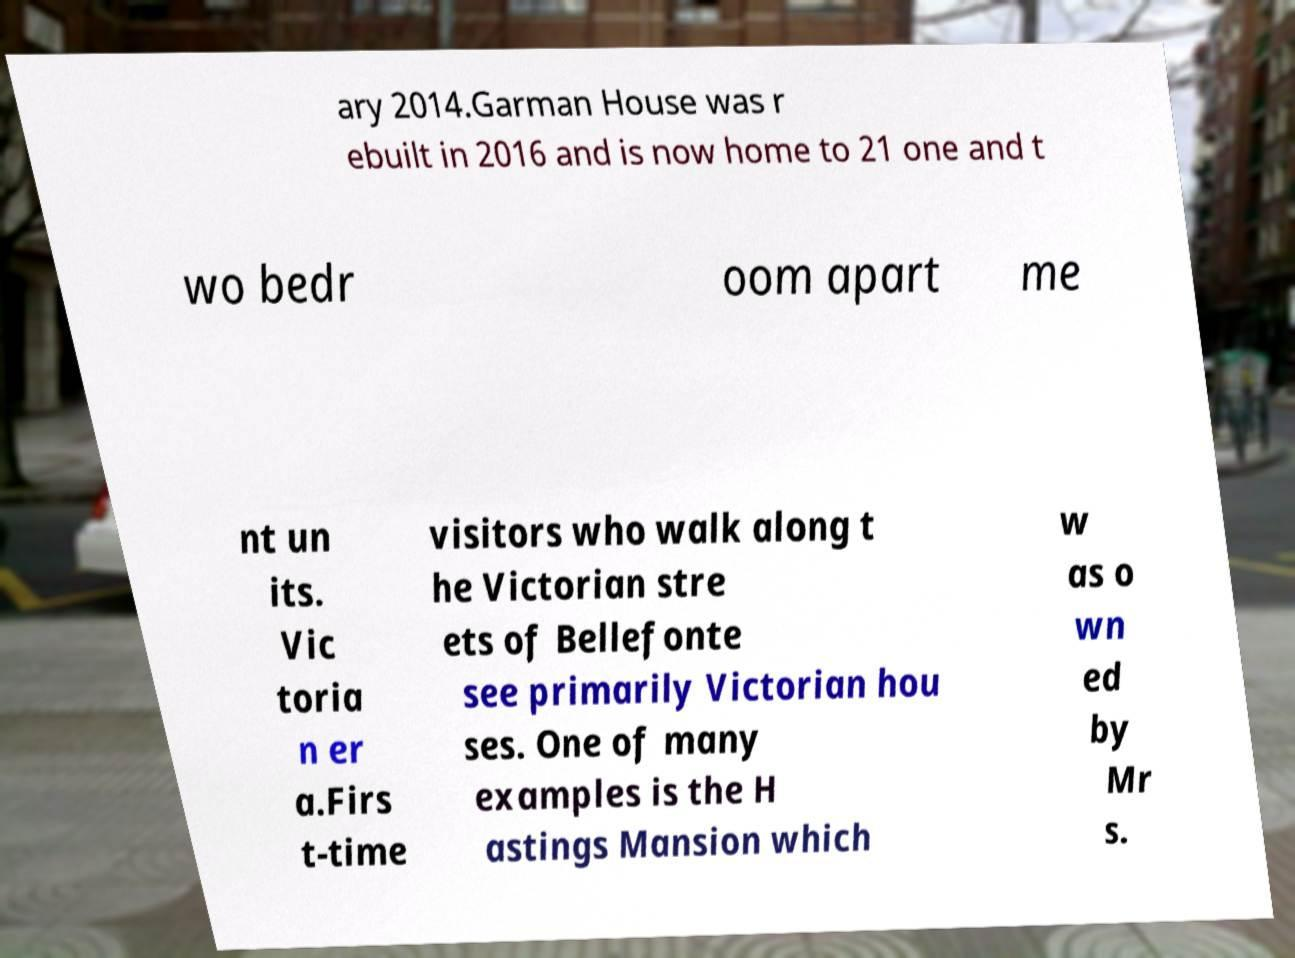Could you extract and type out the text from this image? ary 2014.Garman House was r ebuilt in 2016 and is now home to 21 one and t wo bedr oom apart me nt un its. Vic toria n er a.Firs t-time visitors who walk along t he Victorian stre ets of Bellefonte see primarily Victorian hou ses. One of many examples is the H astings Mansion which w as o wn ed by Mr s. 